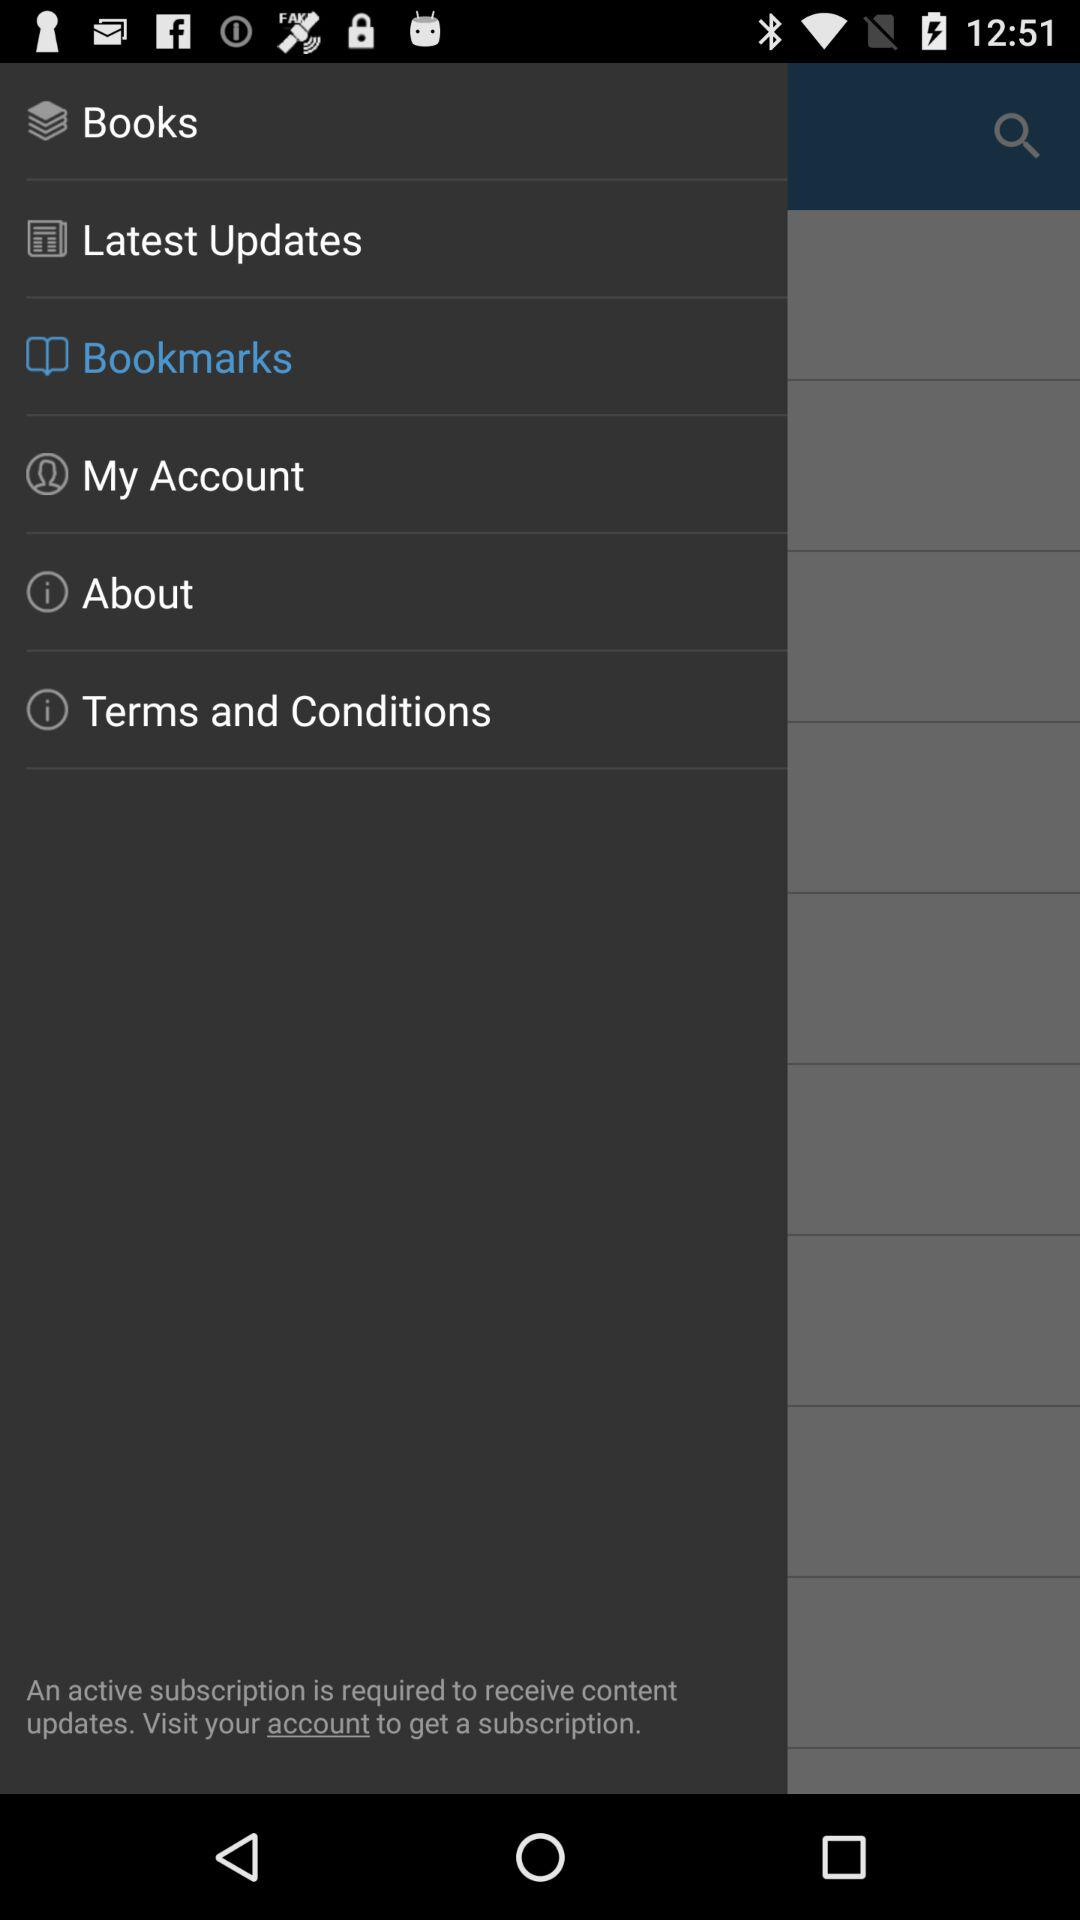Which option is currently selected? The option is "Bookmarks". 